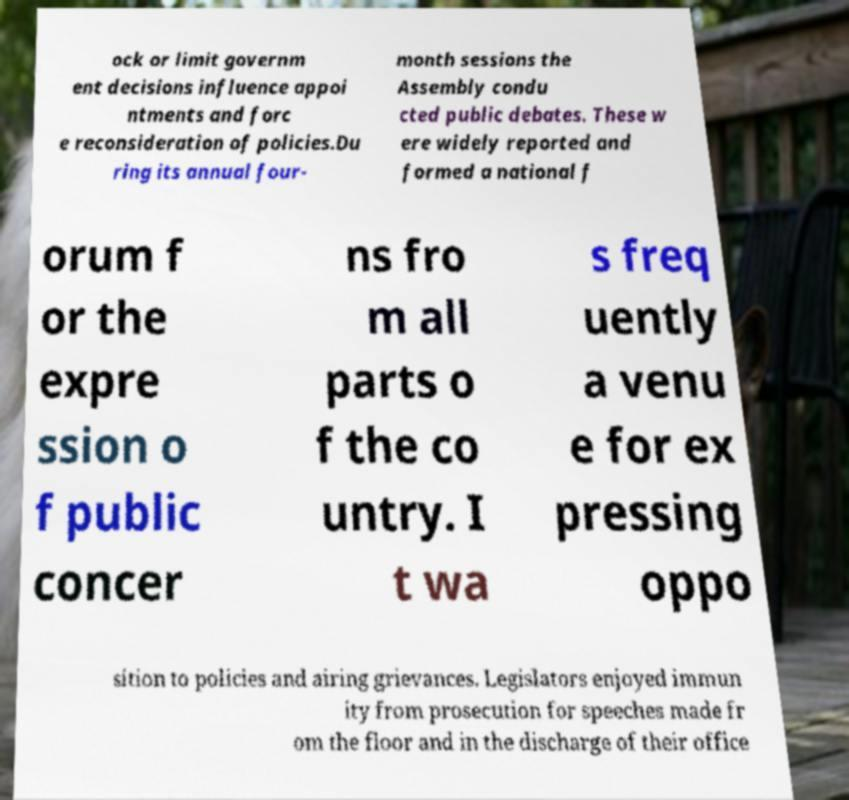Can you read and provide the text displayed in the image?This photo seems to have some interesting text. Can you extract and type it out for me? ock or limit governm ent decisions influence appoi ntments and forc e reconsideration of policies.Du ring its annual four- month sessions the Assembly condu cted public debates. These w ere widely reported and formed a national f orum f or the expre ssion o f public concer ns fro m all parts o f the co untry. I t wa s freq uently a venu e for ex pressing oppo sition to policies and airing grievances. Legislators enjoyed immun ity from prosecution for speeches made fr om the floor and in the discharge of their office 